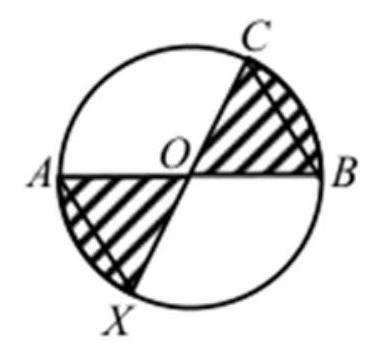The diagram shows a circle with centre $O$ and the diameters $A B$ and $C X$. Let $O B=$ $B C$. Which fraction of the circle area is shaded? To find the fraction of the circle that is shaded, we need to consider the symmetry and the equal lengths of the line segments in the circle. Since OB equals BC and they're radii of the circle, triangle OBC is an isosceles right triangle, and therefore, angle OBC is 45 degrees. The two shaded sections are quarter-circles minus the area of triangle OBC. To determine the exact fraction, the specific measurements or angles of the circle's sectors would be needed, which are not provided in the question. Without this information, a precise fraction cannot be determined. However, understanding these geometric principles can help deduce the correct fraction from the given options by considering the symmetry and relative areas. 